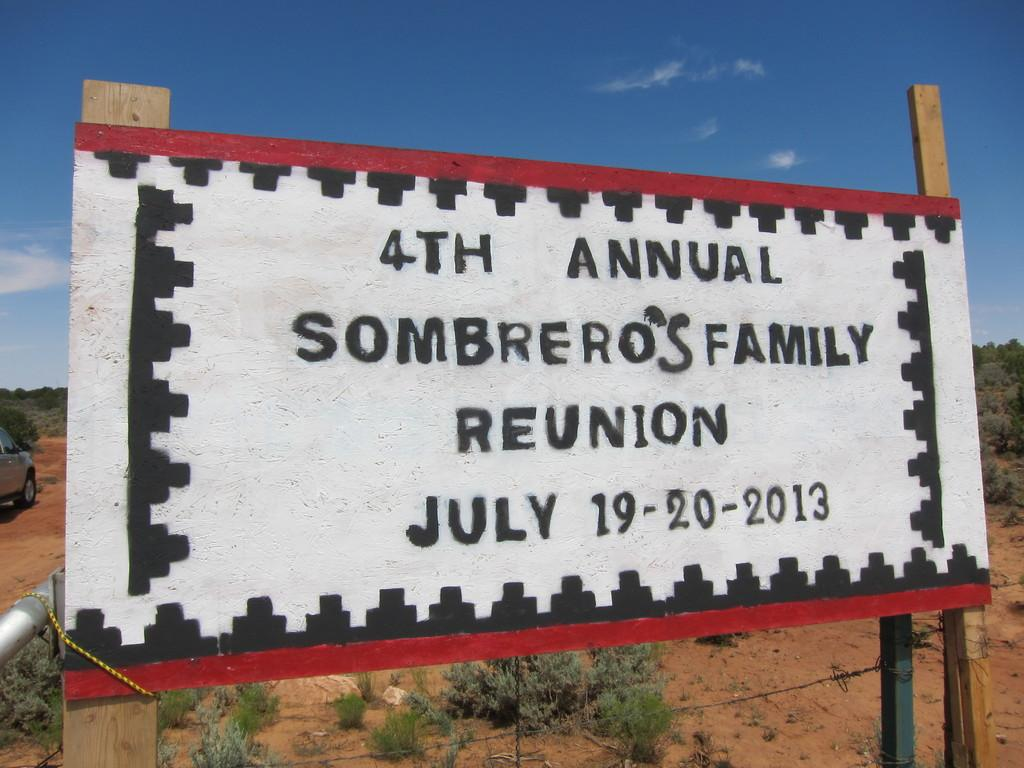<image>
Provide a brief description of the given image. A billboard sits in scrubland and says 4th Annual Sombrero's family reunion July 19-20 2013 